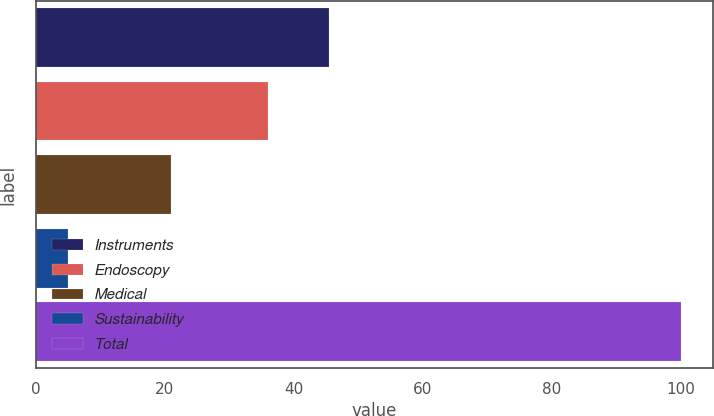Convert chart. <chart><loc_0><loc_0><loc_500><loc_500><bar_chart><fcel>Instruments<fcel>Endoscopy<fcel>Medical<fcel>Sustainability<fcel>Total<nl><fcel>45.5<fcel>36<fcel>21<fcel>5<fcel>100<nl></chart> 